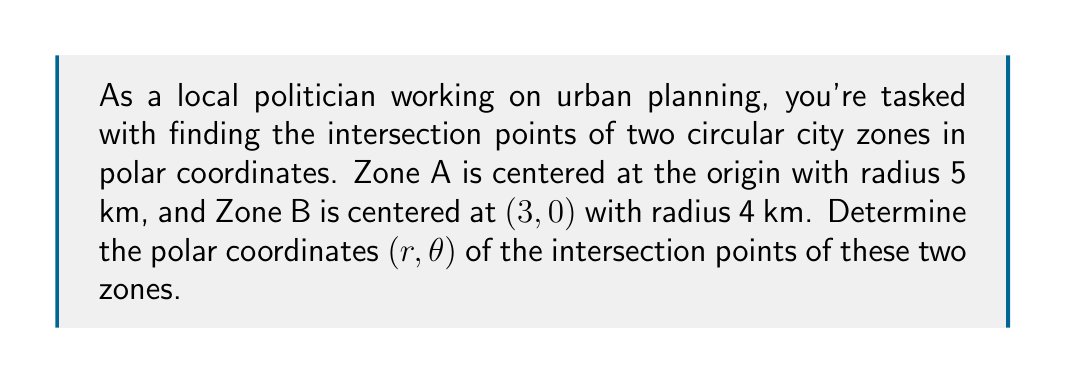Can you solve this math problem? To solve this problem, we'll follow these steps:

1) First, let's visualize the problem:

[asy]
import geometry;

unitsize(1cm);

pair O = (0,0);
pair C = (3,0);

draw(circle(O, 5), blue);
draw(circle(C, 4), red);

dot(O);
dot(C);

label("O", O, SW);
label("C", C, SE);
label("Zone A", (0,5), N);
label("Zone B", (3,4), N);

pair[] intersectionPoints = intersectionpoints(circle(O,5), circle(C,4));
dot(intersectionPoints[0]);
dot(intersectionPoints[1]);

label("P1", intersectionPoints[0], NW);
label("P2", intersectionPoints[1], SW);
[/asy]

2) The equation for Zone A in polar coordinates is simply:

   $$r = 5$$

3) For Zone B, we need to convert its equation from Cartesian to polar coordinates:

   In Cartesian: $(x-3)^2 + y^2 = 4^2$
   
   Substituting $x = r\cos\theta$ and $y = r\sin\theta$:
   
   $$(r\cos\theta - 3)^2 + (r\sin\theta)^2 = 4^2$$

4) Expand this equation:

   $$r^2\cos^2\theta - 6r\cos\theta + 9 + r^2\sin^2\theta = 16$$
   
   $$r^2(\cos^2\theta + \sin^2\theta) - 6r\cos\theta - 7 = 0$$
   
   $$r^2 - 6r\cos\theta - 7 = 0$$

5) At the intersection points, both equations are satisfied. So we can equate $r$ from step 2 to $r$ in the equation from step 4:

   $$5^2 - 6(5)\cos\theta - 7 = 0$$
   
   $$25 - 30\cos\theta - 7 = 0$$
   
   $$18 = 30\cos\theta$$
   
   $$\cos\theta = \frac{3}{5}$$

6) Solve for $\theta$:

   $$\theta = \pm \arccos(\frac{3}{5})$$
   
   $$\theta \approx \pm 0.9273 \text{ radians} \approx \pm 53.13°$$

7) The positive angle corresponds to the upper intersection point, and the negative angle to the lower intersection point.
Answer: The intersection points in polar coordinates $(r, \theta)$ are:

$$(5, 0.9273) \text{ and } (5, -0.9273)$$

or approximately:

$$(5, 53.13°) \text{ and } (5, -53.13°)$$ 